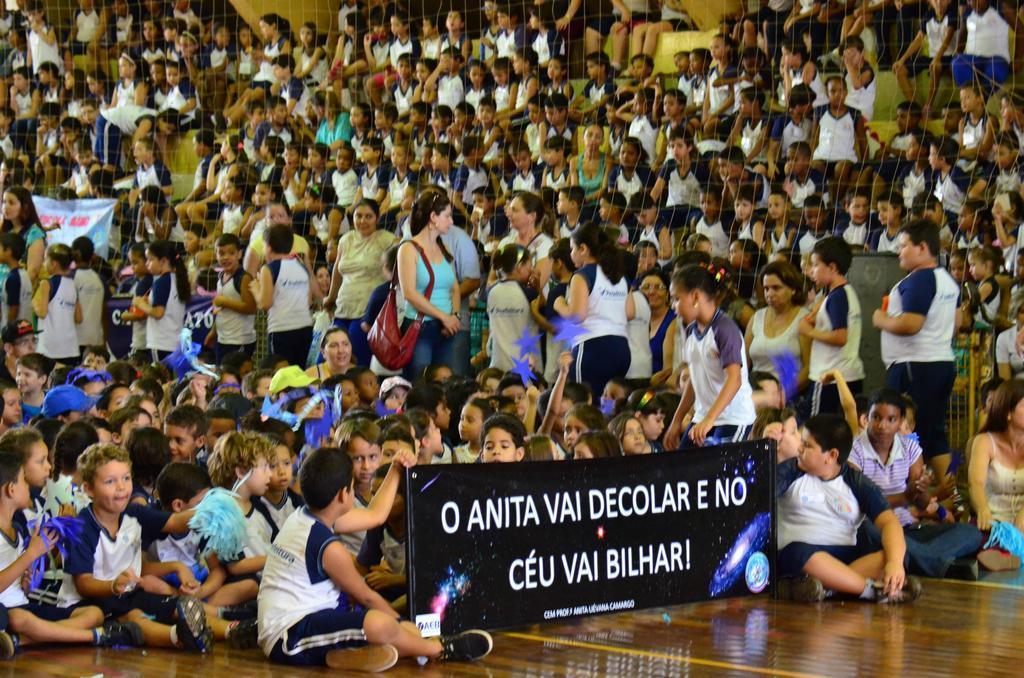How would you summarize this image in a sentence or two? In this image I can see the group of people with different color dresses. I can see one person wearing the bag and few people are holding the banners. In the background I can see the net. 